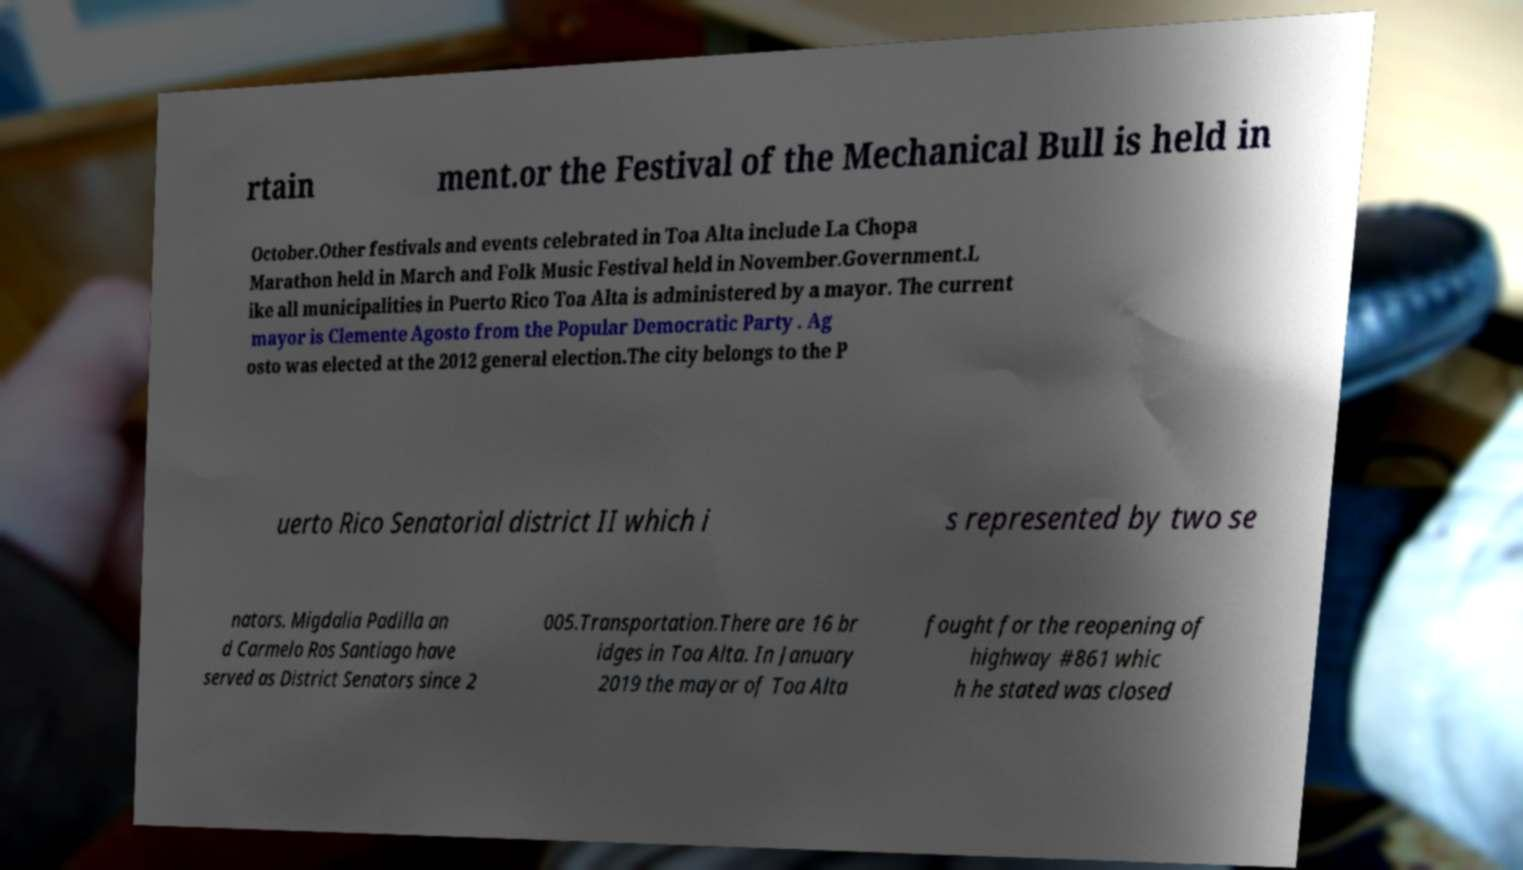Could you extract and type out the text from this image? rtain ment.or the Festival of the Mechanical Bull is held in October.Other festivals and events celebrated in Toa Alta include La Chopa Marathon held in March and Folk Music Festival held in November.Government.L ike all municipalities in Puerto Rico Toa Alta is administered by a mayor. The current mayor is Clemente Agosto from the Popular Democratic Party . Ag osto was elected at the 2012 general election.The city belongs to the P uerto Rico Senatorial district II which i s represented by two se nators. Migdalia Padilla an d Carmelo Ros Santiago have served as District Senators since 2 005.Transportation.There are 16 br idges in Toa Alta. In January 2019 the mayor of Toa Alta fought for the reopening of highway #861 whic h he stated was closed 